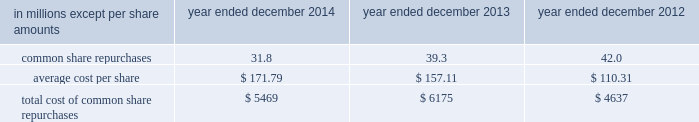Notes to consolidated financial statements guarantees of subsidiaries .
Group inc .
Fully and unconditionally guarantees the securities issued by gs finance corp. , a wholly-owned finance subsidiary of the group inc .
Has guaranteed the payment obligations of goldman , sachs & co .
( gs&co. ) , gs bank usa and goldman sachs execution & clearing , l.p .
( gsec ) , subject to certain exceptions .
In november 2008 , the firm contributed subsidiaries into gs bank usa , and group inc .
Agreed to guarantee the reimbursement of certain losses , including credit-related losses , relating to assets held by the contributed entities .
In connection with this guarantee , group inc .
Also agreed to pledge to gs bank usa certain collateral , including interests in subsidiaries and other illiquid assets .
In addition , group inc .
Guarantees many of the obligations of its other consolidated subsidiaries on a transaction-by- transaction basis , as negotiated with counterparties .
Group inc .
Is unable to develop an estimate of the maximum payout under its subsidiary guarantees ; however , because these guaranteed obligations are also obligations of consolidated subsidiaries , group inc . 2019s liabilities as guarantor are not separately disclosed .
Note 19 .
Shareholders 2019 equity common equity dividends declared per common share were $ 2.25 in 2014 , $ 2.05 in 2013 and $ 1.77 in 2012 .
On january 15 , 2015 , group inc .
Declared a dividend of $ 0.60 per common share to be paid on march 30 , 2015 to common shareholders of record on march 2 , 2015 .
The firm 2019s share repurchase program is intended to help maintain the appropriate level of common equity .
The share repurchase program is effected primarily through regular open-market purchases ( which may include repurchase plans designed to comply with rule 10b5-1 ) , the amounts and timing of which are determined primarily by the firm 2019s current and projected capital position , but which may also be influenced by general market conditions and the prevailing price and trading volumes of the firm 2019s common stock .
Prior to repurchasing common stock , the firm must receive confirmation that the federal reserve board does not object to such capital actions .
The table below presents the amount of common stock repurchased by the firm under the share repurchase program during 2014 , 2013 and 2012. .
Total cost of common share repurchases $ 5469 $ 6175 $ 4637 pursuant to the terms of certain share-based compensation plans , employees may remit shares to the firm or the firm may cancel restricted stock units ( rsus ) or stock options to satisfy minimum statutory employee tax withholding requirements and the exercise price of stock options .
Under these plans , during 2014 , 2013 and 2012 , employees remitted 174489 shares , 161211 shares and 33477 shares with a total value of $ 31 million , $ 25 million and $ 3 million , and the firm cancelled 5.8 million , 4.0 million and 12.7 million of rsus with a total value of $ 974 million , $ 599 million and $ 1.44 billion .
Under these plans , the firm also cancelled 15.6 million stock options with a total value of $ 2.65 billion during 2014 .
170 goldman sachs 2014 annual report .
What was the percentage change in the total cost of common share repurchases between 2013 and 2014? 
Computations: ((5469 - 6175) / 6175)
Answer: -0.11433. 